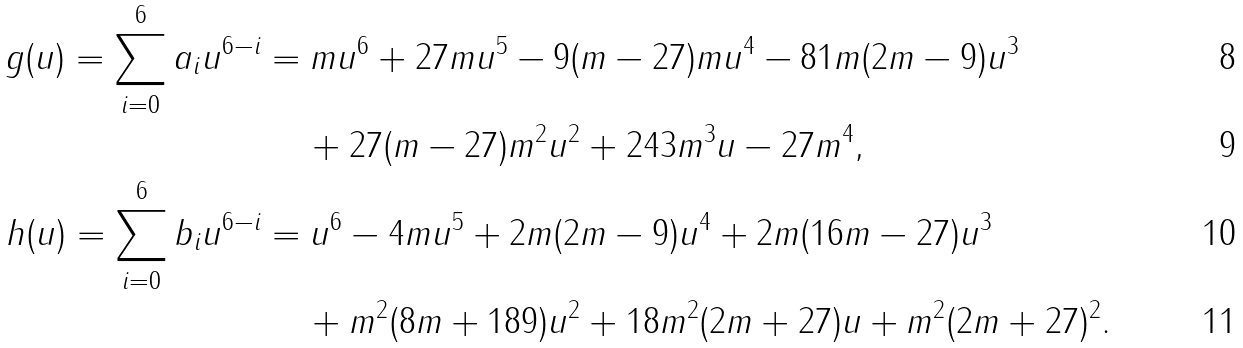Convert formula to latex. <formula><loc_0><loc_0><loc_500><loc_500>g ( u ) = \sum _ { i = 0 } ^ { 6 } a _ { i } u ^ { 6 - i } & = m u ^ { 6 } + 2 7 m u ^ { 5 } - 9 ( m - 2 7 ) m u ^ { 4 } - 8 1 m ( 2 m - 9 ) u ^ { 3 } \\ & \quad \, + 2 7 ( m - 2 7 ) m ^ { 2 } u ^ { 2 } + 2 4 3 m ^ { 3 } u - 2 7 m ^ { 4 } , \\ h ( u ) = \sum _ { i = 0 } ^ { 6 } b _ { i } u ^ { 6 - i } & = u ^ { 6 } - 4 m u ^ { 5 } + 2 m ( 2 m - 9 ) u ^ { 4 } + 2 m ( 1 6 m - 2 7 ) u ^ { 3 } \\ & \quad \, + m ^ { 2 } ( 8 m + 1 8 9 ) u ^ { 2 } + 1 8 m ^ { 2 } ( 2 m + 2 7 ) u + m ^ { 2 } ( 2 m + 2 7 ) ^ { 2 } .</formula> 